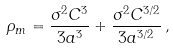Convert formula to latex. <formula><loc_0><loc_0><loc_500><loc_500>\rho _ { m } = \frac { \sigma ^ { 2 } C ^ { 3 } } { 3 a ^ { 3 } } + \frac { \sigma ^ { 2 } C ^ { 3 / 2 } } { 3 a ^ { 3 / 2 } } \, ,</formula> 